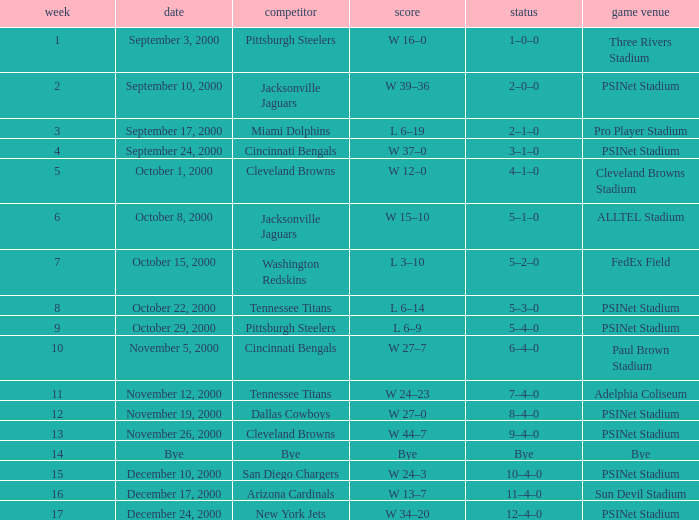What's the record after week 12 with a game site of bye? Bye. 